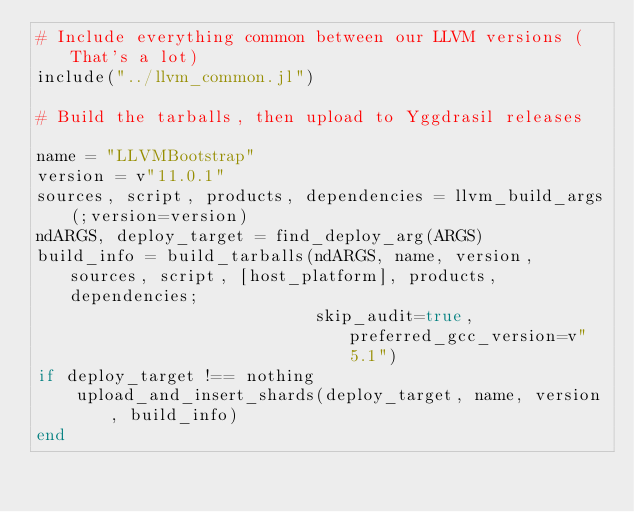<code> <loc_0><loc_0><loc_500><loc_500><_Julia_># Include everything common between our LLVM versions (That's a lot)
include("../llvm_common.jl")

# Build the tarballs, then upload to Yggdrasil releases

name = "LLVMBootstrap"
version = v"11.0.1"
sources, script, products, dependencies = llvm_build_args(;version=version)
ndARGS, deploy_target = find_deploy_arg(ARGS)
build_info = build_tarballs(ndARGS, name, version, sources, script, [host_platform], products, dependencies;
                            skip_audit=true, preferred_gcc_version=v"5.1")
if deploy_target !== nothing
    upload_and_insert_shards(deploy_target, name, version, build_info)
end

</code> 